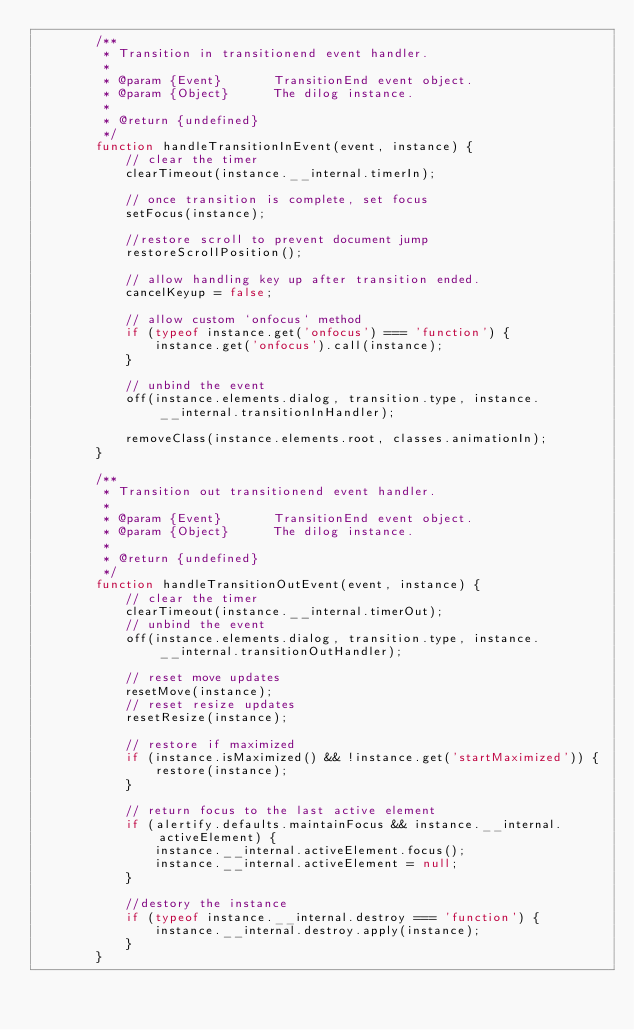Convert code to text. <code><loc_0><loc_0><loc_500><loc_500><_JavaScript_>        /**
         * Transition in transitionend event handler. 
         *
         * @param {Event}		TransitionEnd event object.
         * @param {Object}		The dilog instance.
         *
         * @return {undefined}
         */
        function handleTransitionInEvent(event, instance) {
            // clear the timer
            clearTimeout(instance.__internal.timerIn);

            // once transition is complete, set focus
            setFocus(instance);

            //restore scroll to prevent document jump
            restoreScrollPosition();

            // allow handling key up after transition ended.
            cancelKeyup = false;

            // allow custom `onfocus` method
            if (typeof instance.get('onfocus') === 'function') {
                instance.get('onfocus').call(instance);
            }

            // unbind the event
            off(instance.elements.dialog, transition.type, instance.__internal.transitionInHandler);

            removeClass(instance.elements.root, classes.animationIn);
        }

        /**
         * Transition out transitionend event handler. 
         *
         * @param {Event}		TransitionEnd event object.
         * @param {Object}		The dilog instance.
         *
         * @return {undefined}
         */
        function handleTransitionOutEvent(event, instance) {
            // clear the timer
            clearTimeout(instance.__internal.timerOut);
            // unbind the event
            off(instance.elements.dialog, transition.type, instance.__internal.transitionOutHandler);

            // reset move updates
            resetMove(instance);
            // reset resize updates
            resetResize(instance);

            // restore if maximized
            if (instance.isMaximized() && !instance.get('startMaximized')) {
                restore(instance);
            }

            // return focus to the last active element
            if (alertify.defaults.maintainFocus && instance.__internal.activeElement) {
                instance.__internal.activeElement.focus();
                instance.__internal.activeElement = null;
            }
            
            //destory the instance
            if (typeof instance.__internal.destroy === 'function') {
                instance.__internal.destroy.apply(instance);
            }
        }</code> 